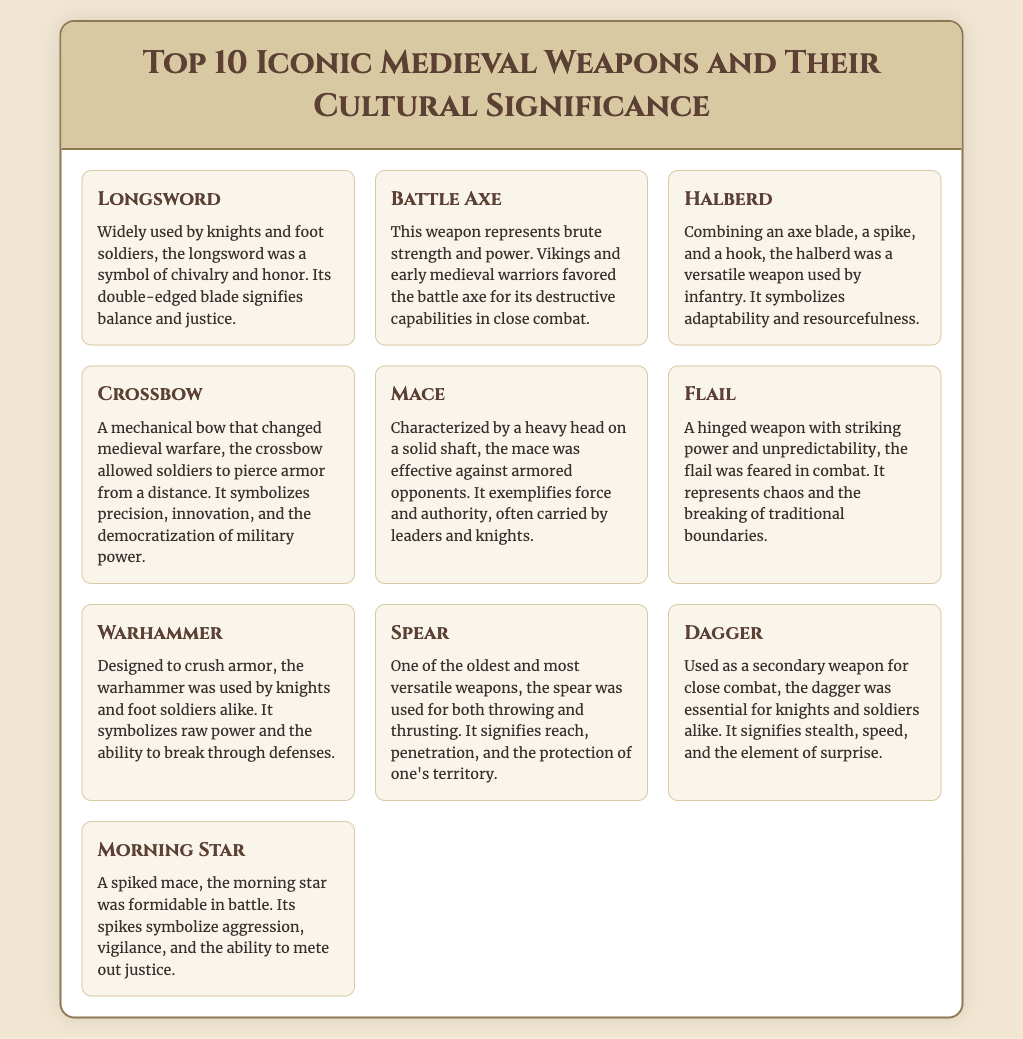What is the first weapon listed? The document lists the weapons in a specific order, with the longsword as the first one mentioned.
Answer: Longsword Which weapon symbolizes adaptability? The halberd is described as a versatile weapon, representing adaptability and resourcefulness.
Answer: Halberd How many weapons are listed in total? The document clearly states that there are ten weapons being discussed.
Answer: 10 What does the flail represent in combat? The flail is described as symbolizing chaos and the breaking of traditional boundaries in combat.
Answer: Chaos Which weapon was favored by Vikings? The battle axe is identified as a favored weapon of Vikings due to its destructive capabilities.
Answer: Battle Axe What is a defining characteristic of the mace? It is characterized by a heavy head on a solid shaft, making it effective against armored opponents.
Answer: Heavy head Which weapon signifies raw power? The warhammer is mentioned as symbolizing raw power, particularly in breaking through defenses.
Answer: Warhammer What type of weapon is the morning star? The morning star is specified as a spiked mace that was formidable in battle.
Answer: Spiked mace What is unique about the crossbow's impact on warfare? The crossbow allowed soldiers to pierce armor from a distance, indicating its innovative role in changing warfare.
Answer: Innovative Which weapon emphasizes stealth and speed? The dagger is identified as a secondary weapon that signifies stealth, speed, and the element of surprise.
Answer: Dagger 